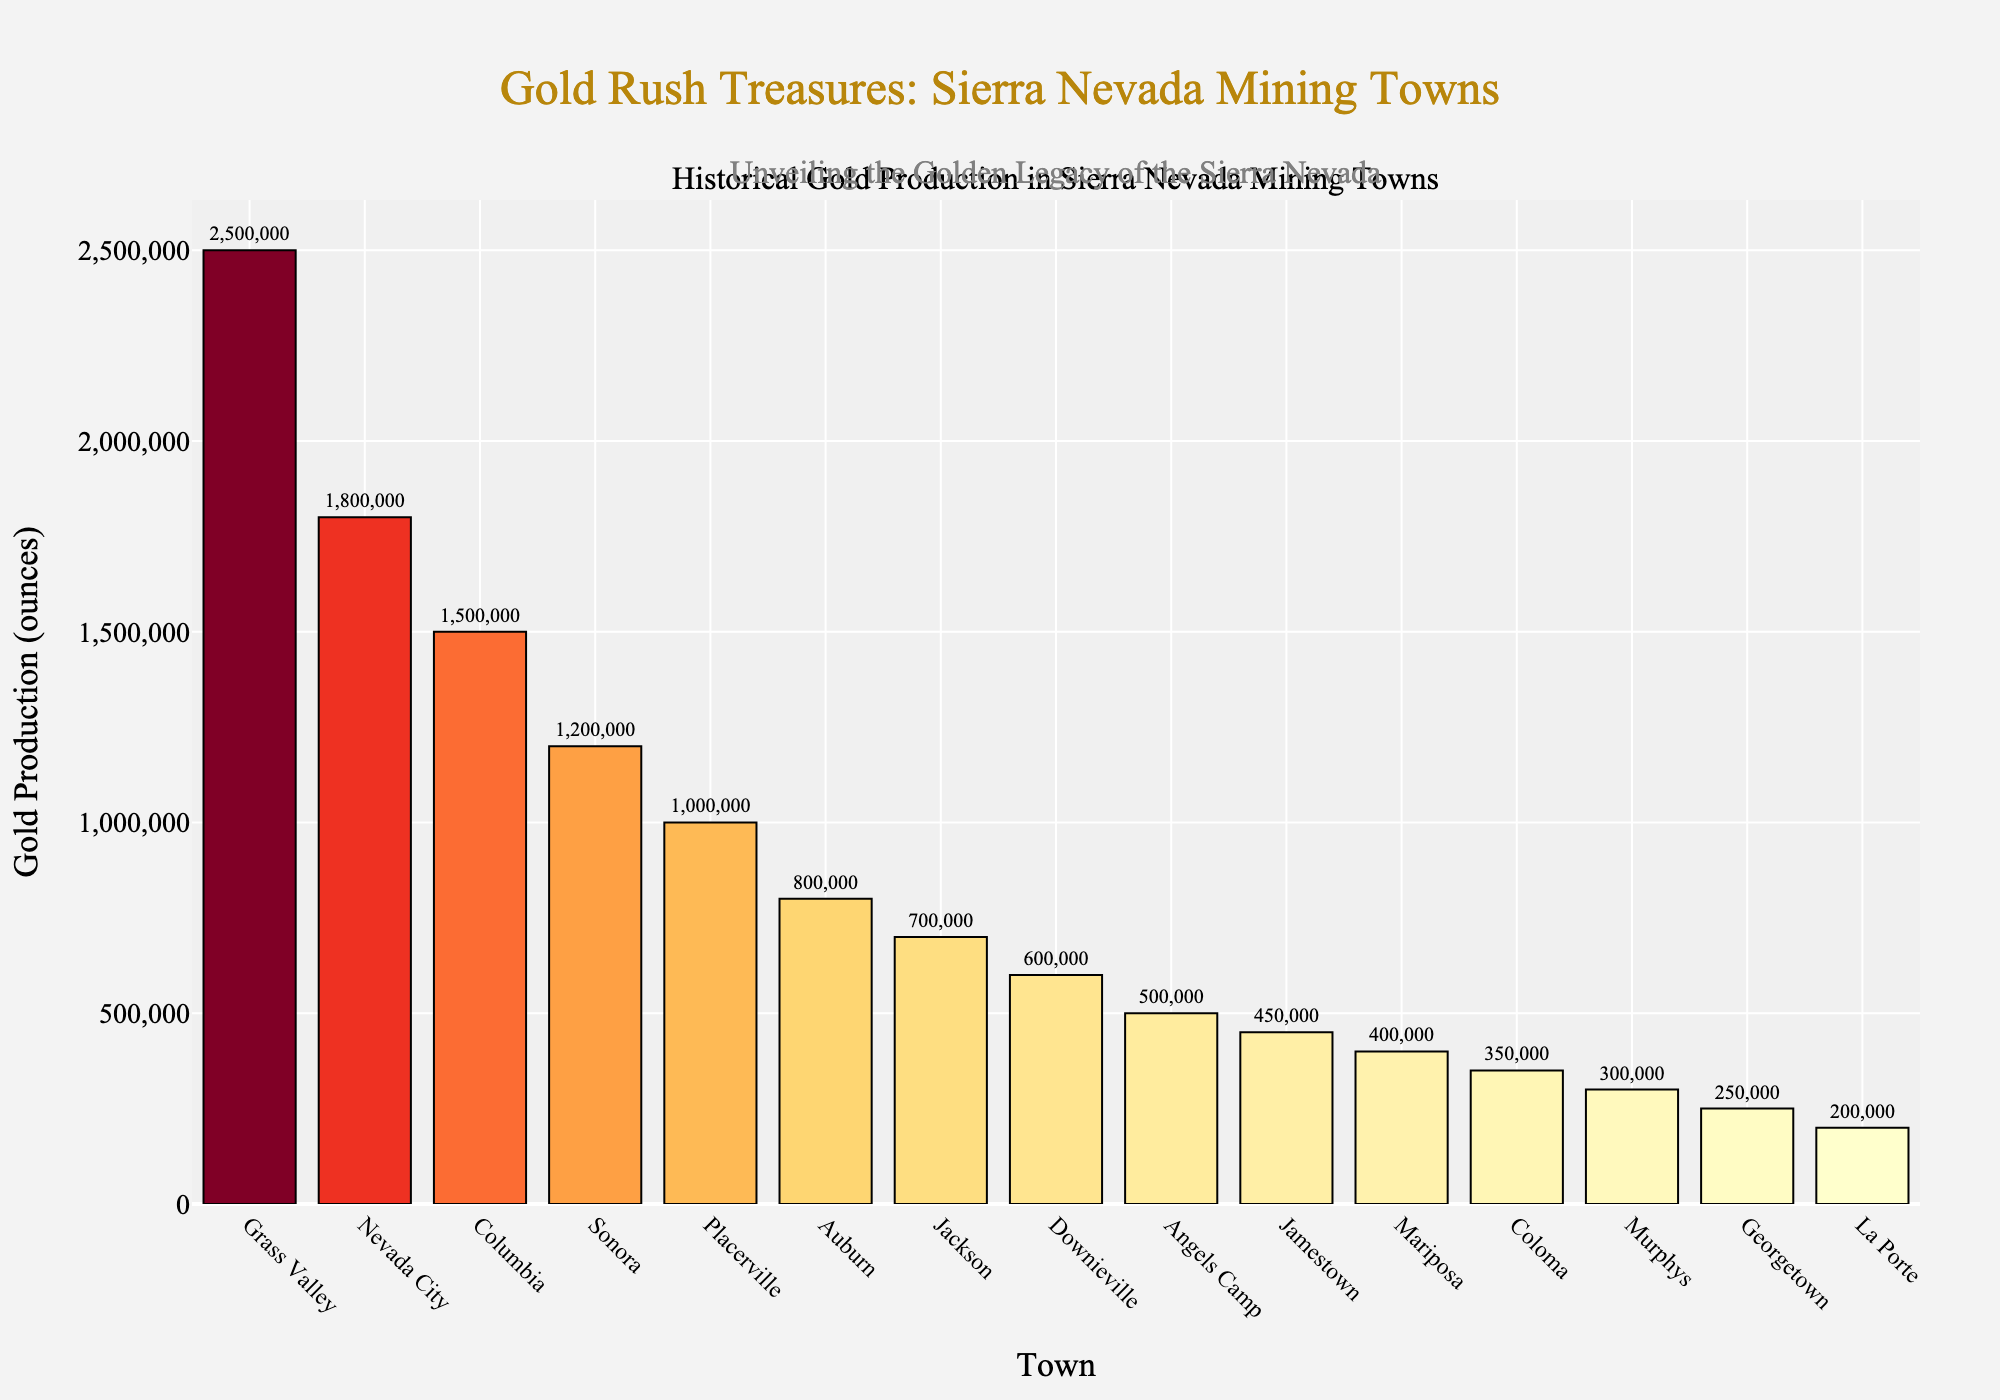What are the top three mining towns in terms of gold production? Grass Valley, Nevada City, and Columbia have the highest gold production values according to the chart. By observing the tallest bars, we can identify Grass Valley with 2,500,000 ounces, Nevada City with 1,800,000 ounces, and Columbia with 1,500,000 ounces.
Answer: Grass Valley, Nevada City, Columbia Which town had the least gold production? The shortest bar in the chart represents La Porte, indicating that it had the least gold production among the listed towns, with 200,000 ounces.
Answer: La Porte How much more gold did Grass Valley produce compared to Sonora? Grass Valley produced 2,500,000 ounces of gold, while Sonora produced 1,200,000 ounces. The difference can be calculated as 2,500,000 - 1,200,000 = 1,300,000 ounces.
Answer: 1,300,000 ounces What is the combined gold production of Downieville and Angels Camp? Downieville produced 600,000 ounces, and Angels Camp produced 500,000 ounces. Adding these values, we get 600,000 + 500,000 = 1,100,000 ounces.
Answer: 1,100,000 ounces Which towns produced between 500,000 and 1,000,000 ounces of gold? Observing the bars in the specified range, we can see that Auburn, Jackson, and Downieville produced within the given range: Auburn (800,000), Jackson (700,000), and Downieville (600,000).
Answer: Auburn, Jackson, Downieville How many towns produced more than 1,000,000 ounces of gold? By counting the bars extending beyond 1,000,000 ounces, we find five towns: Grass Valley, Nevada City, Columbia, Sonora, and Placerville.
Answer: Five towns What is the average gold production of Murphys, Georgetown, and La Porte? Sum of gold production values for these towns is 300,000 (Murphys) + 250,000 (Georgetown) + 200,000 (La Porte) = 750,000 ounces. The average is 750,000 / 3 = 250,000 ounces.
Answer: 250,000 ounces Compare the gold production of Columbia and Placerville. Columbia produced 1,500,000 ounces of gold, while Placerville produced 1,000,000 ounces. Columbia's production is greater by 500,000 ounces.
Answer: Columbia produced more by 500,000 ounces What are the visual characteristics of the bar representing Nevada City? The bar for Nevada City is the second tallest, colored in a shade of orange-red, and has a height indicating 1,800,000 ounces of gold production.
Answer: Tall, orange-red, 1,800,000 ounces How much gold combined did Jamestown and Mariposa produce? Jamestown produced 450,000 ounces and Mariposa produced 400,000 ounces. Their combined production is 450,000 + 400,000 = 850,000 ounces.
Answer: 850,000 ounces 